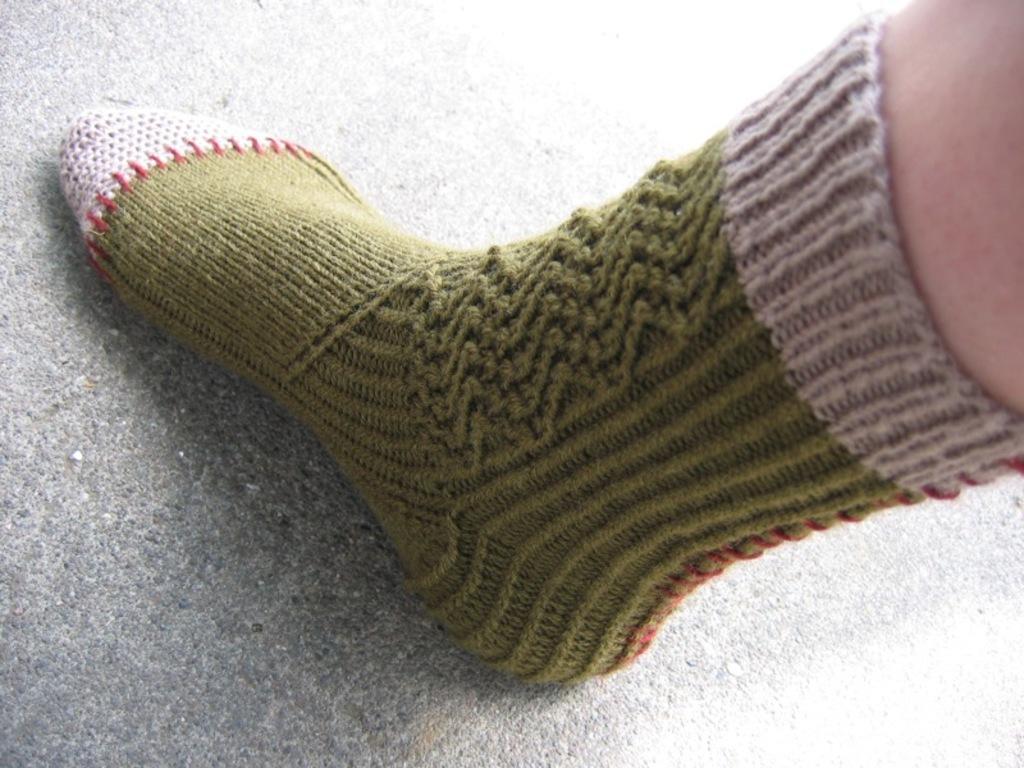In one or two sentences, can you explain what this image depicts? In this image we can see a person wearing a sock. 